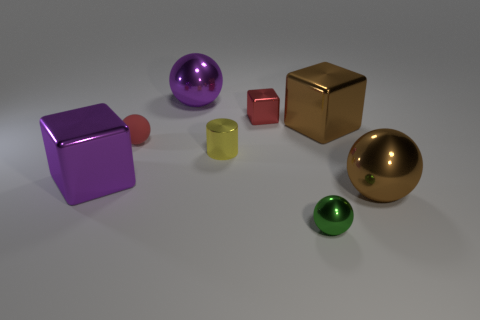What color is the big metal ball in front of the large purple object in front of the small red metal block?
Keep it short and to the point. Brown. What number of other objects are there of the same shape as the small green object?
Provide a succinct answer. 3. Is there a large purple object that has the same material as the yellow object?
Provide a succinct answer. Yes. What material is the red sphere that is the same size as the metal cylinder?
Offer a terse response. Rubber. There is a sphere left of the purple metallic thing on the right side of the large cube on the left side of the yellow cylinder; what is its color?
Your response must be concise. Red. There is a tiny shiny thing in front of the shiny cylinder; is it the same shape as the large brown shiny thing that is in front of the rubber ball?
Offer a terse response. Yes. What number of big metal spheres are there?
Your response must be concise. 2. What color is the other sphere that is the same size as the brown metallic sphere?
Offer a very short reply. Purple. Is the brown thing that is behind the purple block made of the same material as the tiny red thing that is left of the red shiny block?
Offer a terse response. No. What size is the metal ball that is left of the tiny object that is behind the brown block?
Your answer should be compact. Large. 